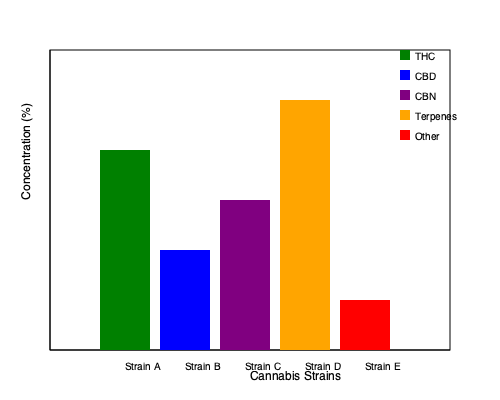Based on the bar graph comparing different cannabis strain profiles, which strain has the highest concentration of terpenes? To determine which strain has the highest concentration of terpenes, we need to follow these steps:

1. Identify the color representing terpenes in the legend (orange).
2. Examine the orange bars for each strain in the graph.
3. Compare the heights of the orange bars, as height represents concentration.
4. Identify the tallest orange bar.

Looking at the graph:

- Strain A: No visible orange bar
- Strain B: No visible orange bar
- Strain C: No visible orange bar
- Strain D: Tall orange bar, reaching about 25% concentration
- Strain E: No visible orange bar

The tallest (and only visible) orange bar corresponds to Strain D, indicating it has the highest concentration of terpenes among the strains shown.
Answer: Strain D 